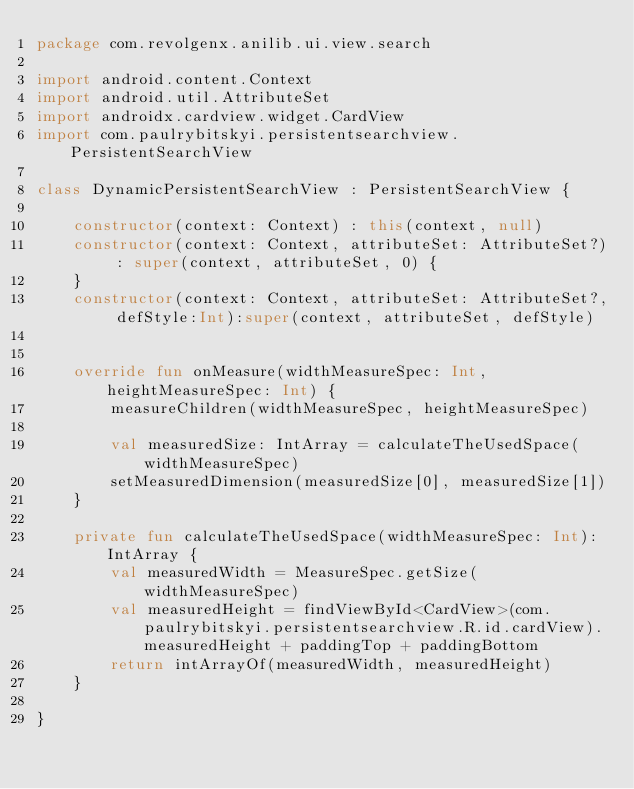Convert code to text. <code><loc_0><loc_0><loc_500><loc_500><_Kotlin_>package com.revolgenx.anilib.ui.view.search

import android.content.Context
import android.util.AttributeSet
import androidx.cardview.widget.CardView
import com.paulrybitskyi.persistentsearchview.PersistentSearchView

class DynamicPersistentSearchView : PersistentSearchView {

    constructor(context: Context) : this(context, null)
    constructor(context: Context, attributeSet: AttributeSet?) : super(context, attributeSet, 0) {
    }
    constructor(context: Context, attributeSet: AttributeSet?, defStyle:Int):super(context, attributeSet, defStyle)


    override fun onMeasure(widthMeasureSpec: Int, heightMeasureSpec: Int) {
        measureChildren(widthMeasureSpec, heightMeasureSpec)

        val measuredSize: IntArray = calculateTheUsedSpace(widthMeasureSpec)
        setMeasuredDimension(measuredSize[0], measuredSize[1])
    }

    private fun calculateTheUsedSpace(widthMeasureSpec: Int): IntArray {
        val measuredWidth = MeasureSpec.getSize(widthMeasureSpec)
        val measuredHeight = findViewById<CardView>(com.paulrybitskyi.persistentsearchview.R.id.cardView).measuredHeight + paddingTop + paddingBottom
        return intArrayOf(measuredWidth, measuredHeight)
    }

}</code> 